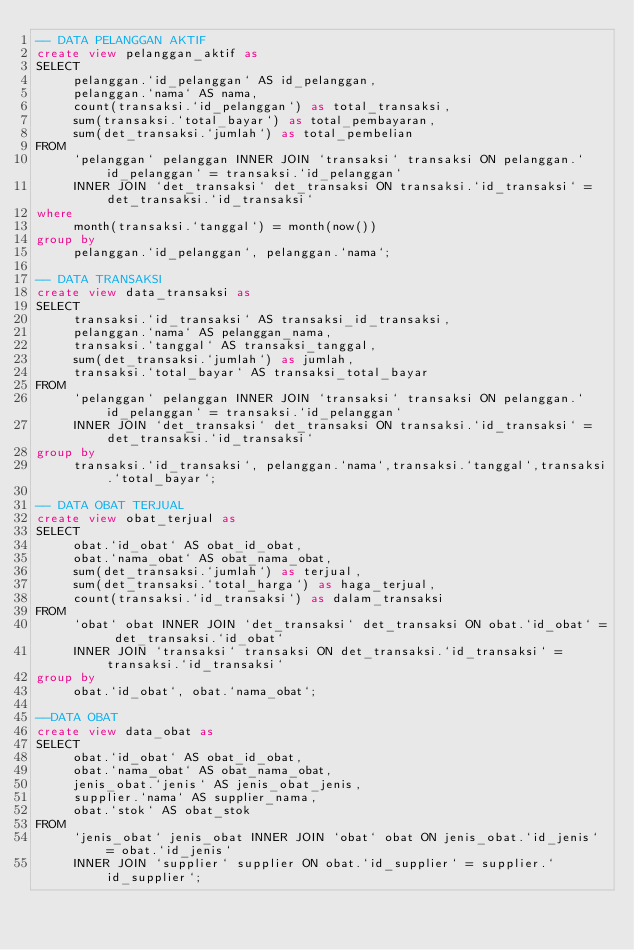Convert code to text. <code><loc_0><loc_0><loc_500><loc_500><_SQL_>-- DATA PELANGGAN AKTIF
create view pelanggan_aktif as
SELECT
     pelanggan.`id_pelanggan` AS id_pelanggan,
     pelanggan.`nama` AS nama,
     count(transaksi.`id_pelanggan`) as total_transaksi,
     sum(transaksi.`total_bayar`) as total_pembayaran,
     sum(det_transaksi.`jumlah`) as total_pembelian
FROM
     `pelanggan` pelanggan INNER JOIN `transaksi` transaksi ON pelanggan.`id_pelanggan` = transaksi.`id_pelanggan`
     INNER JOIN `det_transaksi` det_transaksi ON transaksi.`id_transaksi` = det_transaksi.`id_transaksi`
where 
     month(transaksi.`tanggal`) = month(now()) 
group by 
     pelanggan.`id_pelanggan`, pelanggan.`nama`;

-- DATA TRANSAKSI
create view data_transaksi as
SELECT
     transaksi.`id_transaksi` AS transaksi_id_transaksi,
     pelanggan.`nama` AS pelanggan_nama,
     transaksi.`tanggal` AS transaksi_tanggal,
     sum(det_transaksi.`jumlah`) as jumlah,
     transaksi.`total_bayar` AS transaksi_total_bayar
FROM
     `pelanggan` pelanggan INNER JOIN `transaksi` transaksi ON pelanggan.`id_pelanggan` = transaksi.`id_pelanggan`
     INNER JOIN `det_transaksi` det_transaksi ON transaksi.`id_transaksi` = det_transaksi.`id_transaksi`
group by
     transaksi.`id_transaksi`, pelanggan.`nama`,transaksi.`tanggal`,transaksi.`total_bayar`;

-- DATA OBAT TERJUAL
create view obat_terjual as
SELECT
     obat.`id_obat` AS obat_id_obat,
     obat.`nama_obat` AS obat_nama_obat,
     sum(det_transaksi.`jumlah`) as terjual,
     sum(det_transaksi.`total_harga`) as haga_terjual,
     count(transaksi.`id_transaksi`) as dalam_transaksi
FROM
     `obat` obat INNER JOIN `det_transaksi` det_transaksi ON obat.`id_obat` = det_transaksi.`id_obat`
     INNER JOIN `transaksi` transaksi ON det_transaksi.`id_transaksi` = transaksi.`id_transaksi`
group by
     obat.`id_obat`, obat.`nama_obat`;

--DATA OBAT
create view data_obat as
SELECT
     obat.`id_obat` AS obat_id_obat,
     obat.`nama_obat` AS obat_nama_obat,
     jenis_obat.`jenis` AS jenis_obat_jenis,
     supplier.`nama` AS supplier_nama,
     obat.`stok` AS obat_stok
FROM
     `jenis_obat` jenis_obat INNER JOIN `obat` obat ON jenis_obat.`id_jenis` = obat.`id_jenis`
     INNER JOIN `supplier` supplier ON obat.`id_supplier` = supplier.`id_supplier`;

</code> 